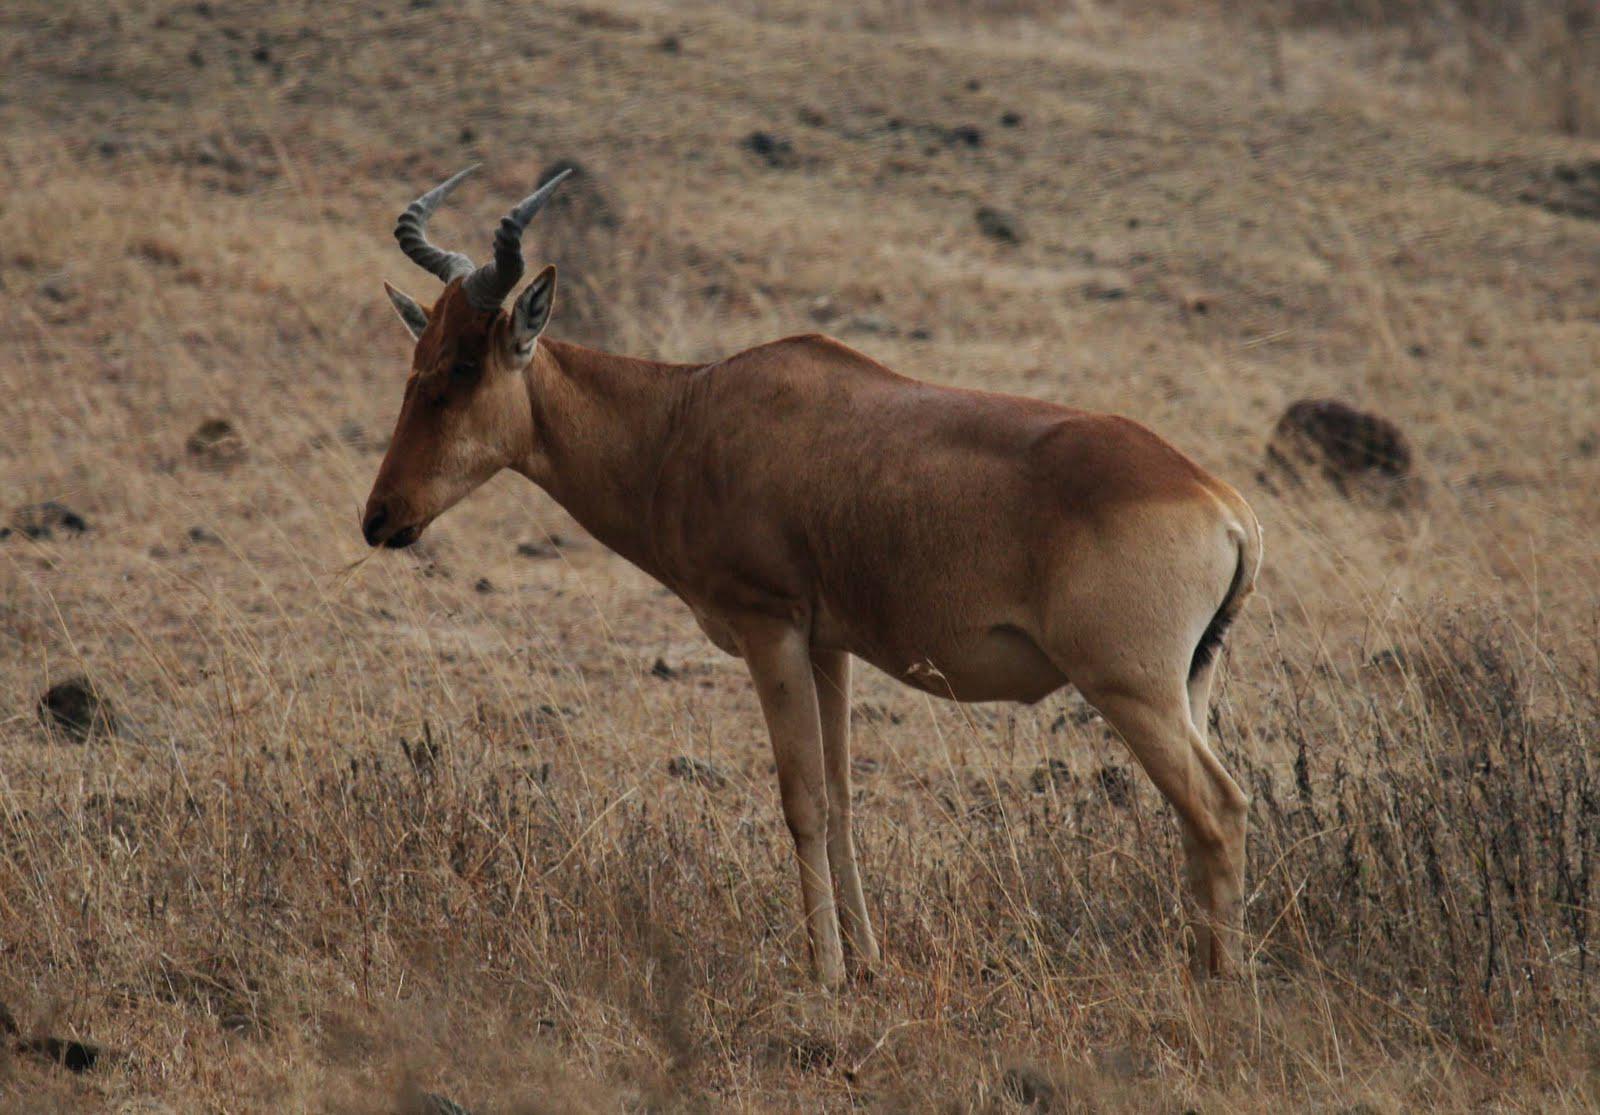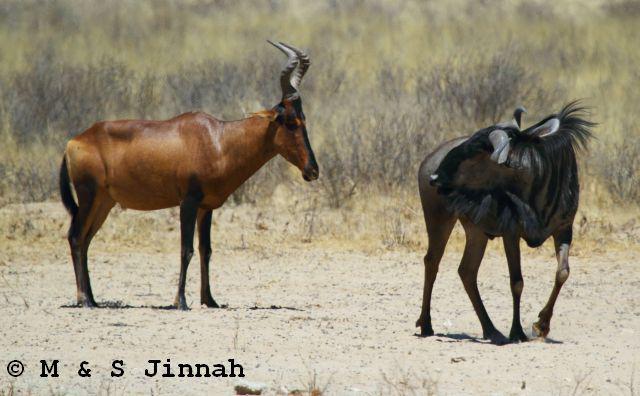The first image is the image on the left, the second image is the image on the right. Assess this claim about the two images: "There are two antelopes, both facing left.". Correct or not? Answer yes or no. No. The first image is the image on the left, the second image is the image on the right. Evaluate the accuracy of this statement regarding the images: "Each image contains a single horned animal in the foreground, and the animal's body is turned leftward.". Is it true? Answer yes or no. No. 